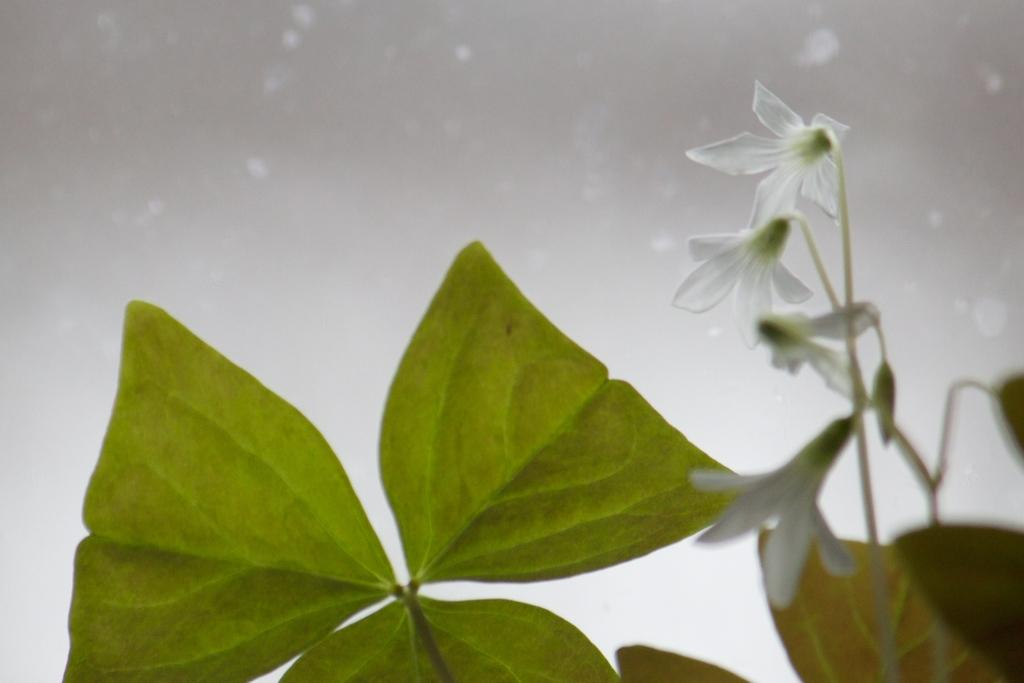What type of vegetation is present at the bottom of the image? There are leaves at the bottom of the image. What type of flowers can be seen at the right side of the image? There are white color flowers at the right side of the image. What can be seen in the background of the image? The sky is visible in the background of the image. How many shoes are visible in the image? There are no shoes present in the image. What type of action is being performed by the eggs in the image? There are no eggs present in the image, so no action can be observed. 